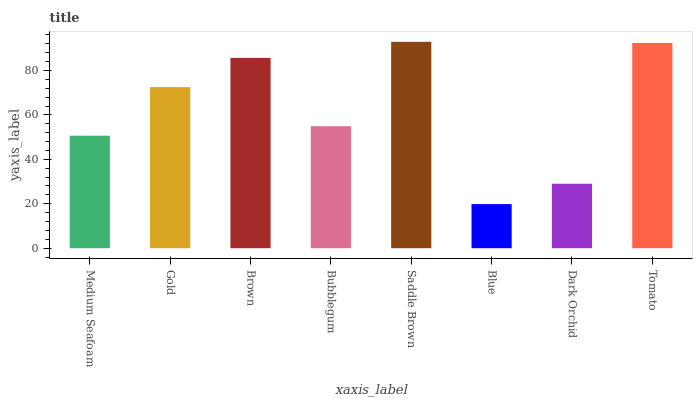Is Blue the minimum?
Answer yes or no. Yes. Is Saddle Brown the maximum?
Answer yes or no. Yes. Is Gold the minimum?
Answer yes or no. No. Is Gold the maximum?
Answer yes or no. No. Is Gold greater than Medium Seafoam?
Answer yes or no. Yes. Is Medium Seafoam less than Gold?
Answer yes or no. Yes. Is Medium Seafoam greater than Gold?
Answer yes or no. No. Is Gold less than Medium Seafoam?
Answer yes or no. No. Is Gold the high median?
Answer yes or no. Yes. Is Bubblegum the low median?
Answer yes or no. Yes. Is Blue the high median?
Answer yes or no. No. Is Tomato the low median?
Answer yes or no. No. 